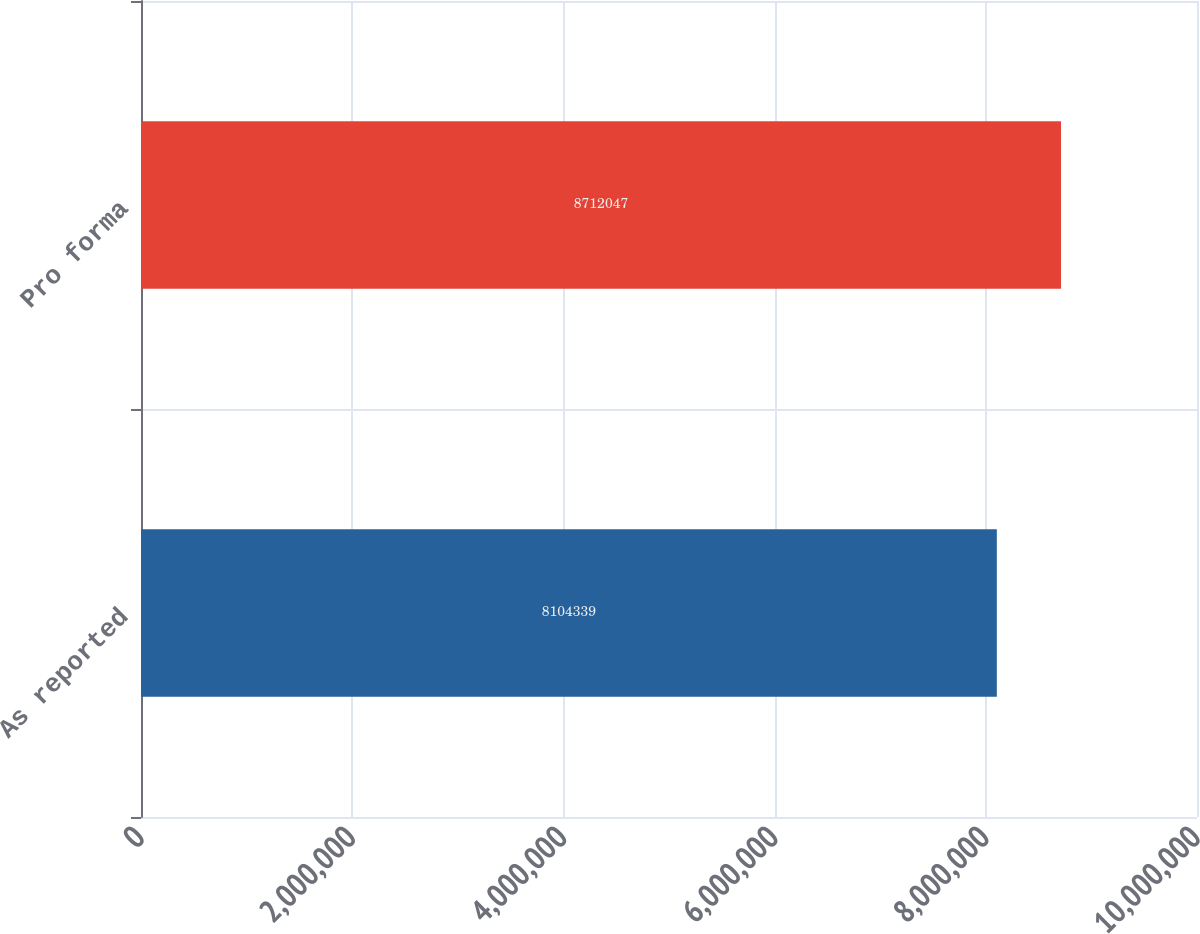<chart> <loc_0><loc_0><loc_500><loc_500><bar_chart><fcel>As reported<fcel>Pro forma<nl><fcel>8.10434e+06<fcel>8.71205e+06<nl></chart> 